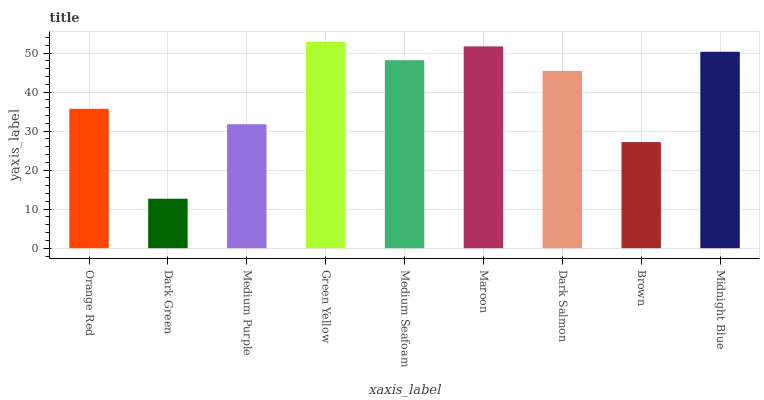Is Dark Green the minimum?
Answer yes or no. Yes. Is Green Yellow the maximum?
Answer yes or no. Yes. Is Medium Purple the minimum?
Answer yes or no. No. Is Medium Purple the maximum?
Answer yes or no. No. Is Medium Purple greater than Dark Green?
Answer yes or no. Yes. Is Dark Green less than Medium Purple?
Answer yes or no. Yes. Is Dark Green greater than Medium Purple?
Answer yes or no. No. Is Medium Purple less than Dark Green?
Answer yes or no. No. Is Dark Salmon the high median?
Answer yes or no. Yes. Is Dark Salmon the low median?
Answer yes or no. Yes. Is Maroon the high median?
Answer yes or no. No. Is Medium Purple the low median?
Answer yes or no. No. 